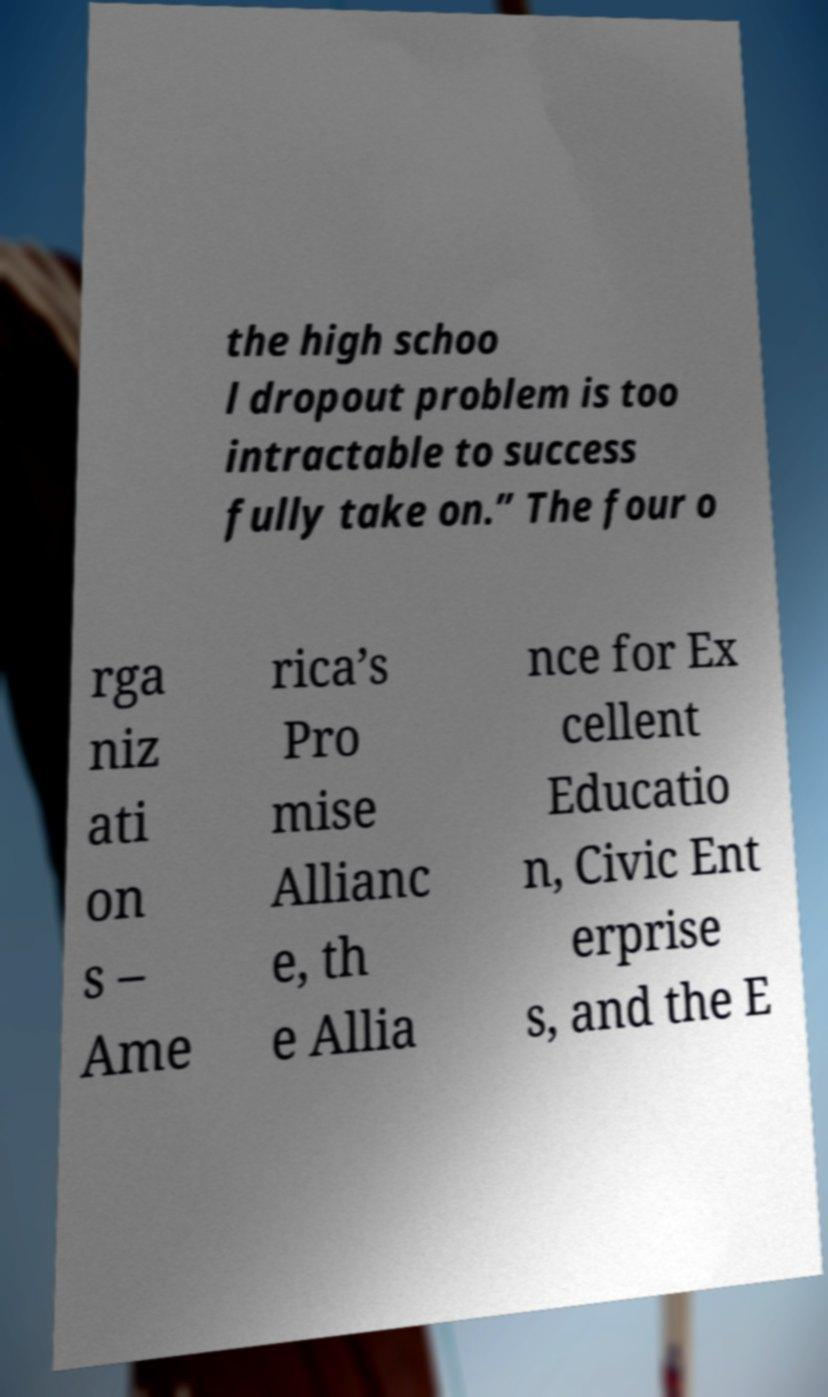Please read and relay the text visible in this image. What does it say? the high schoo l dropout problem is too intractable to success fully take on.” The four o rga niz ati on s – Ame rica’s Pro mise Allianc e, th e Allia nce for Ex cellent Educatio n, Civic Ent erprise s, and the E 